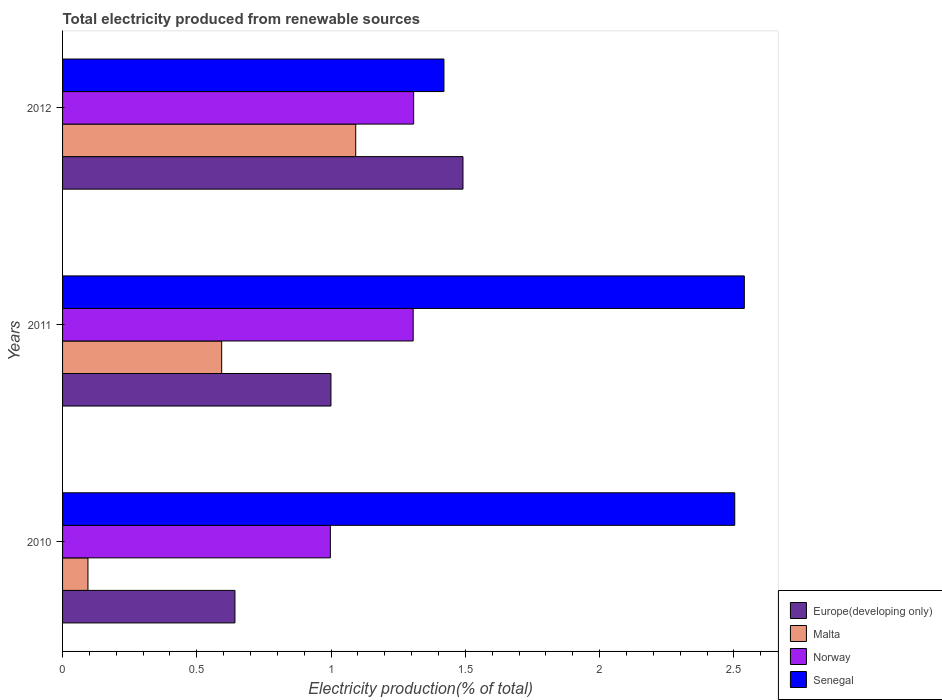How many different coloured bars are there?
Offer a terse response. 4. Are the number of bars per tick equal to the number of legend labels?
Your answer should be compact. Yes. How many bars are there on the 1st tick from the top?
Offer a terse response. 4. How many bars are there on the 1st tick from the bottom?
Your answer should be very brief. 4. In how many cases, is the number of bars for a given year not equal to the number of legend labels?
Give a very brief answer. 0. What is the total electricity produced in Malta in 2010?
Provide a short and direct response. 0.09. Across all years, what is the maximum total electricity produced in Norway?
Keep it short and to the point. 1.31. Across all years, what is the minimum total electricity produced in Norway?
Make the answer very short. 1. In which year was the total electricity produced in Malta maximum?
Your answer should be compact. 2012. What is the total total electricity produced in Malta in the graph?
Ensure brevity in your answer.  1.78. What is the difference between the total electricity produced in Malta in 2011 and that in 2012?
Your response must be concise. -0.5. What is the difference between the total electricity produced in Norway in 2011 and the total electricity produced in Europe(developing only) in 2012?
Offer a very short reply. -0.19. What is the average total electricity produced in Norway per year?
Give a very brief answer. 1.2. In the year 2012, what is the difference between the total electricity produced in Europe(developing only) and total electricity produced in Norway?
Ensure brevity in your answer.  0.18. What is the ratio of the total electricity produced in Europe(developing only) in 2010 to that in 2011?
Make the answer very short. 0.64. Is the difference between the total electricity produced in Europe(developing only) in 2011 and 2012 greater than the difference between the total electricity produced in Norway in 2011 and 2012?
Your answer should be compact. No. What is the difference between the highest and the second highest total electricity produced in Senegal?
Offer a terse response. 0.04. What is the difference between the highest and the lowest total electricity produced in Norway?
Your answer should be compact. 0.31. In how many years, is the total electricity produced in Malta greater than the average total electricity produced in Malta taken over all years?
Your answer should be compact. 1. Is it the case that in every year, the sum of the total electricity produced in Norway and total electricity produced in Europe(developing only) is greater than the sum of total electricity produced in Senegal and total electricity produced in Malta?
Offer a very short reply. No. What does the 3rd bar from the top in 2011 represents?
Offer a very short reply. Malta. What does the 1st bar from the bottom in 2012 represents?
Your answer should be very brief. Europe(developing only). Is it the case that in every year, the sum of the total electricity produced in Norway and total electricity produced in Europe(developing only) is greater than the total electricity produced in Malta?
Ensure brevity in your answer.  Yes. How many years are there in the graph?
Make the answer very short. 3. What is the difference between two consecutive major ticks on the X-axis?
Ensure brevity in your answer.  0.5. Where does the legend appear in the graph?
Your answer should be compact. Bottom right. How many legend labels are there?
Make the answer very short. 4. What is the title of the graph?
Keep it short and to the point. Total electricity produced from renewable sources. What is the label or title of the Y-axis?
Make the answer very short. Years. What is the Electricity production(% of total) of Europe(developing only) in 2010?
Offer a very short reply. 0.64. What is the Electricity production(% of total) of Malta in 2010?
Keep it short and to the point. 0.09. What is the Electricity production(% of total) of Norway in 2010?
Your answer should be compact. 1. What is the Electricity production(% of total) in Senegal in 2010?
Your answer should be very brief. 2.5. What is the Electricity production(% of total) of Europe(developing only) in 2011?
Give a very brief answer. 1. What is the Electricity production(% of total) of Malta in 2011?
Your answer should be very brief. 0.59. What is the Electricity production(% of total) of Norway in 2011?
Keep it short and to the point. 1.31. What is the Electricity production(% of total) of Senegal in 2011?
Your answer should be compact. 2.54. What is the Electricity production(% of total) in Europe(developing only) in 2012?
Your response must be concise. 1.49. What is the Electricity production(% of total) in Malta in 2012?
Offer a very short reply. 1.09. What is the Electricity production(% of total) of Norway in 2012?
Your answer should be very brief. 1.31. What is the Electricity production(% of total) in Senegal in 2012?
Give a very brief answer. 1.42. Across all years, what is the maximum Electricity production(% of total) of Europe(developing only)?
Make the answer very short. 1.49. Across all years, what is the maximum Electricity production(% of total) in Malta?
Offer a very short reply. 1.09. Across all years, what is the maximum Electricity production(% of total) in Norway?
Offer a very short reply. 1.31. Across all years, what is the maximum Electricity production(% of total) in Senegal?
Provide a short and direct response. 2.54. Across all years, what is the minimum Electricity production(% of total) in Europe(developing only)?
Provide a succinct answer. 0.64. Across all years, what is the minimum Electricity production(% of total) in Malta?
Offer a very short reply. 0.09. Across all years, what is the minimum Electricity production(% of total) of Norway?
Your response must be concise. 1. Across all years, what is the minimum Electricity production(% of total) of Senegal?
Offer a very short reply. 1.42. What is the total Electricity production(% of total) in Europe(developing only) in the graph?
Your response must be concise. 3.13. What is the total Electricity production(% of total) of Malta in the graph?
Your answer should be compact. 1.78. What is the total Electricity production(% of total) of Norway in the graph?
Provide a short and direct response. 3.61. What is the total Electricity production(% of total) of Senegal in the graph?
Give a very brief answer. 6.46. What is the difference between the Electricity production(% of total) in Europe(developing only) in 2010 and that in 2011?
Your answer should be very brief. -0.36. What is the difference between the Electricity production(% of total) of Malta in 2010 and that in 2011?
Keep it short and to the point. -0.5. What is the difference between the Electricity production(% of total) of Norway in 2010 and that in 2011?
Your response must be concise. -0.31. What is the difference between the Electricity production(% of total) in Senegal in 2010 and that in 2011?
Provide a short and direct response. -0.04. What is the difference between the Electricity production(% of total) in Europe(developing only) in 2010 and that in 2012?
Keep it short and to the point. -0.85. What is the difference between the Electricity production(% of total) in Malta in 2010 and that in 2012?
Provide a succinct answer. -1. What is the difference between the Electricity production(% of total) in Norway in 2010 and that in 2012?
Ensure brevity in your answer.  -0.31. What is the difference between the Electricity production(% of total) in Senegal in 2010 and that in 2012?
Your answer should be compact. 1.08. What is the difference between the Electricity production(% of total) in Europe(developing only) in 2011 and that in 2012?
Keep it short and to the point. -0.49. What is the difference between the Electricity production(% of total) in Malta in 2011 and that in 2012?
Keep it short and to the point. -0.5. What is the difference between the Electricity production(% of total) of Norway in 2011 and that in 2012?
Your response must be concise. -0. What is the difference between the Electricity production(% of total) of Senegal in 2011 and that in 2012?
Your answer should be compact. 1.12. What is the difference between the Electricity production(% of total) in Europe(developing only) in 2010 and the Electricity production(% of total) in Malta in 2011?
Provide a short and direct response. 0.05. What is the difference between the Electricity production(% of total) of Europe(developing only) in 2010 and the Electricity production(% of total) of Norway in 2011?
Ensure brevity in your answer.  -0.66. What is the difference between the Electricity production(% of total) of Europe(developing only) in 2010 and the Electricity production(% of total) of Senegal in 2011?
Offer a very short reply. -1.9. What is the difference between the Electricity production(% of total) of Malta in 2010 and the Electricity production(% of total) of Norway in 2011?
Keep it short and to the point. -1.21. What is the difference between the Electricity production(% of total) in Malta in 2010 and the Electricity production(% of total) in Senegal in 2011?
Offer a terse response. -2.44. What is the difference between the Electricity production(% of total) in Norway in 2010 and the Electricity production(% of total) in Senegal in 2011?
Your response must be concise. -1.54. What is the difference between the Electricity production(% of total) in Europe(developing only) in 2010 and the Electricity production(% of total) in Malta in 2012?
Provide a short and direct response. -0.45. What is the difference between the Electricity production(% of total) of Europe(developing only) in 2010 and the Electricity production(% of total) of Norway in 2012?
Offer a very short reply. -0.67. What is the difference between the Electricity production(% of total) of Europe(developing only) in 2010 and the Electricity production(% of total) of Senegal in 2012?
Keep it short and to the point. -0.78. What is the difference between the Electricity production(% of total) of Malta in 2010 and the Electricity production(% of total) of Norway in 2012?
Provide a succinct answer. -1.21. What is the difference between the Electricity production(% of total) in Malta in 2010 and the Electricity production(% of total) in Senegal in 2012?
Provide a short and direct response. -1.33. What is the difference between the Electricity production(% of total) in Norway in 2010 and the Electricity production(% of total) in Senegal in 2012?
Provide a succinct answer. -0.42. What is the difference between the Electricity production(% of total) of Europe(developing only) in 2011 and the Electricity production(% of total) of Malta in 2012?
Your answer should be very brief. -0.09. What is the difference between the Electricity production(% of total) of Europe(developing only) in 2011 and the Electricity production(% of total) of Norway in 2012?
Give a very brief answer. -0.31. What is the difference between the Electricity production(% of total) in Europe(developing only) in 2011 and the Electricity production(% of total) in Senegal in 2012?
Ensure brevity in your answer.  -0.42. What is the difference between the Electricity production(% of total) in Malta in 2011 and the Electricity production(% of total) in Norway in 2012?
Give a very brief answer. -0.71. What is the difference between the Electricity production(% of total) in Malta in 2011 and the Electricity production(% of total) in Senegal in 2012?
Provide a short and direct response. -0.83. What is the difference between the Electricity production(% of total) of Norway in 2011 and the Electricity production(% of total) of Senegal in 2012?
Your answer should be very brief. -0.11. What is the average Electricity production(% of total) of Europe(developing only) per year?
Your answer should be compact. 1.04. What is the average Electricity production(% of total) in Malta per year?
Your response must be concise. 0.59. What is the average Electricity production(% of total) in Norway per year?
Keep it short and to the point. 1.2. What is the average Electricity production(% of total) of Senegal per year?
Provide a succinct answer. 2.15. In the year 2010, what is the difference between the Electricity production(% of total) of Europe(developing only) and Electricity production(% of total) of Malta?
Offer a terse response. 0.55. In the year 2010, what is the difference between the Electricity production(% of total) in Europe(developing only) and Electricity production(% of total) in Norway?
Your answer should be very brief. -0.36. In the year 2010, what is the difference between the Electricity production(% of total) of Europe(developing only) and Electricity production(% of total) of Senegal?
Give a very brief answer. -1.86. In the year 2010, what is the difference between the Electricity production(% of total) of Malta and Electricity production(% of total) of Norway?
Ensure brevity in your answer.  -0.9. In the year 2010, what is the difference between the Electricity production(% of total) in Malta and Electricity production(% of total) in Senegal?
Your answer should be very brief. -2.41. In the year 2010, what is the difference between the Electricity production(% of total) in Norway and Electricity production(% of total) in Senegal?
Your answer should be very brief. -1.51. In the year 2011, what is the difference between the Electricity production(% of total) in Europe(developing only) and Electricity production(% of total) in Malta?
Ensure brevity in your answer.  0.41. In the year 2011, what is the difference between the Electricity production(% of total) of Europe(developing only) and Electricity production(% of total) of Norway?
Keep it short and to the point. -0.31. In the year 2011, what is the difference between the Electricity production(% of total) in Europe(developing only) and Electricity production(% of total) in Senegal?
Provide a succinct answer. -1.54. In the year 2011, what is the difference between the Electricity production(% of total) of Malta and Electricity production(% of total) of Norway?
Your answer should be very brief. -0.71. In the year 2011, what is the difference between the Electricity production(% of total) in Malta and Electricity production(% of total) in Senegal?
Make the answer very short. -1.95. In the year 2011, what is the difference between the Electricity production(% of total) in Norway and Electricity production(% of total) in Senegal?
Your response must be concise. -1.23. In the year 2012, what is the difference between the Electricity production(% of total) in Europe(developing only) and Electricity production(% of total) in Malta?
Offer a terse response. 0.4. In the year 2012, what is the difference between the Electricity production(% of total) of Europe(developing only) and Electricity production(% of total) of Norway?
Your answer should be very brief. 0.18. In the year 2012, what is the difference between the Electricity production(% of total) in Europe(developing only) and Electricity production(% of total) in Senegal?
Provide a short and direct response. 0.07. In the year 2012, what is the difference between the Electricity production(% of total) in Malta and Electricity production(% of total) in Norway?
Offer a terse response. -0.22. In the year 2012, what is the difference between the Electricity production(% of total) of Malta and Electricity production(% of total) of Senegal?
Provide a succinct answer. -0.33. In the year 2012, what is the difference between the Electricity production(% of total) of Norway and Electricity production(% of total) of Senegal?
Make the answer very short. -0.11. What is the ratio of the Electricity production(% of total) in Europe(developing only) in 2010 to that in 2011?
Your answer should be compact. 0.64. What is the ratio of the Electricity production(% of total) of Malta in 2010 to that in 2011?
Provide a short and direct response. 0.16. What is the ratio of the Electricity production(% of total) of Norway in 2010 to that in 2011?
Offer a very short reply. 0.76. What is the ratio of the Electricity production(% of total) of Europe(developing only) in 2010 to that in 2012?
Offer a terse response. 0.43. What is the ratio of the Electricity production(% of total) in Malta in 2010 to that in 2012?
Your answer should be very brief. 0.09. What is the ratio of the Electricity production(% of total) of Norway in 2010 to that in 2012?
Your response must be concise. 0.76. What is the ratio of the Electricity production(% of total) of Senegal in 2010 to that in 2012?
Ensure brevity in your answer.  1.76. What is the ratio of the Electricity production(% of total) in Europe(developing only) in 2011 to that in 2012?
Your answer should be compact. 0.67. What is the ratio of the Electricity production(% of total) in Malta in 2011 to that in 2012?
Your response must be concise. 0.54. What is the ratio of the Electricity production(% of total) of Senegal in 2011 to that in 2012?
Ensure brevity in your answer.  1.79. What is the difference between the highest and the second highest Electricity production(% of total) in Europe(developing only)?
Make the answer very short. 0.49. What is the difference between the highest and the second highest Electricity production(% of total) of Malta?
Give a very brief answer. 0.5. What is the difference between the highest and the second highest Electricity production(% of total) of Norway?
Your answer should be compact. 0. What is the difference between the highest and the second highest Electricity production(% of total) in Senegal?
Your response must be concise. 0.04. What is the difference between the highest and the lowest Electricity production(% of total) of Europe(developing only)?
Make the answer very short. 0.85. What is the difference between the highest and the lowest Electricity production(% of total) in Norway?
Your answer should be very brief. 0.31. What is the difference between the highest and the lowest Electricity production(% of total) in Senegal?
Your answer should be very brief. 1.12. 